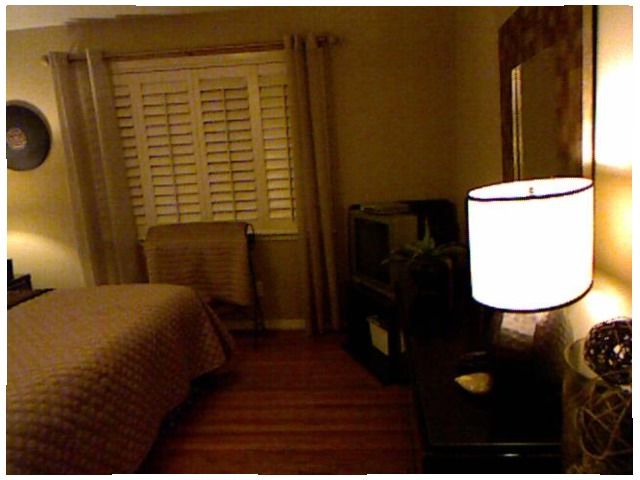<image>
Is there a window in front of the bed? Yes. The window is positioned in front of the bed, appearing closer to the camera viewpoint. Where is the shutter in relation to the curtains? Is it behind the curtains? Yes. From this viewpoint, the shutter is positioned behind the curtains, with the curtains partially or fully occluding the shutter. Is there a shade in the window? Yes. The shade is contained within or inside the window, showing a containment relationship. 